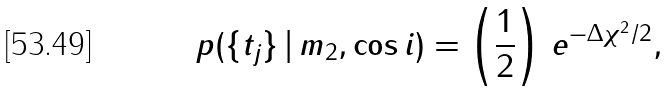<formula> <loc_0><loc_0><loc_500><loc_500>p ( \{ t _ { j } \} \, | \, m _ { 2 } , \cos { i } ) = \left ( \frac { 1 } { 2 } \right ) \, e ^ { - \Delta \chi ^ { 2 } / 2 } ,</formula> 